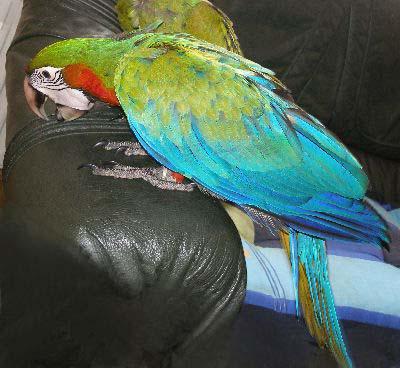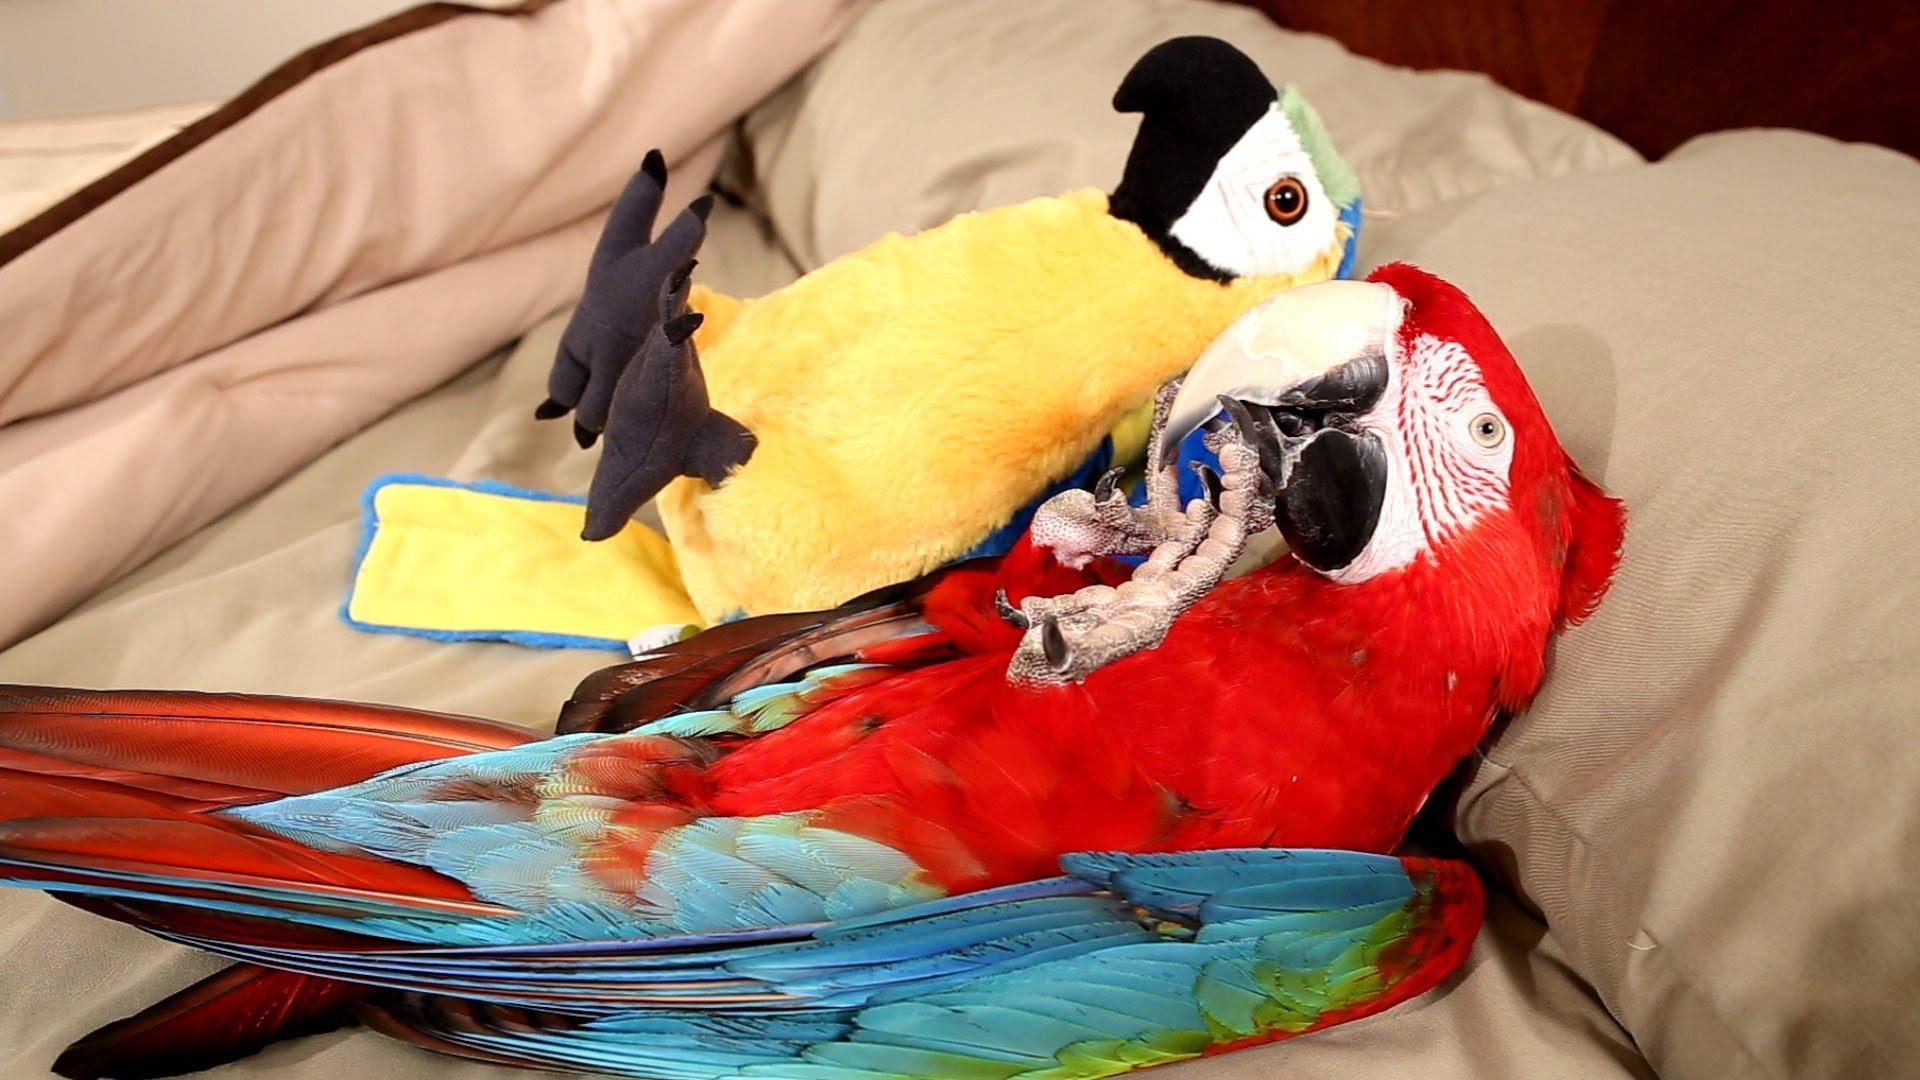The first image is the image on the left, the second image is the image on the right. Analyze the images presented: Is the assertion "A parrot with a red head is sleeping outdoors." valid? Answer yes or no. No. The first image is the image on the left, the second image is the image on the right. Given the left and right images, does the statement "The parrot in the right image has a red head." hold true? Answer yes or no. Yes. 